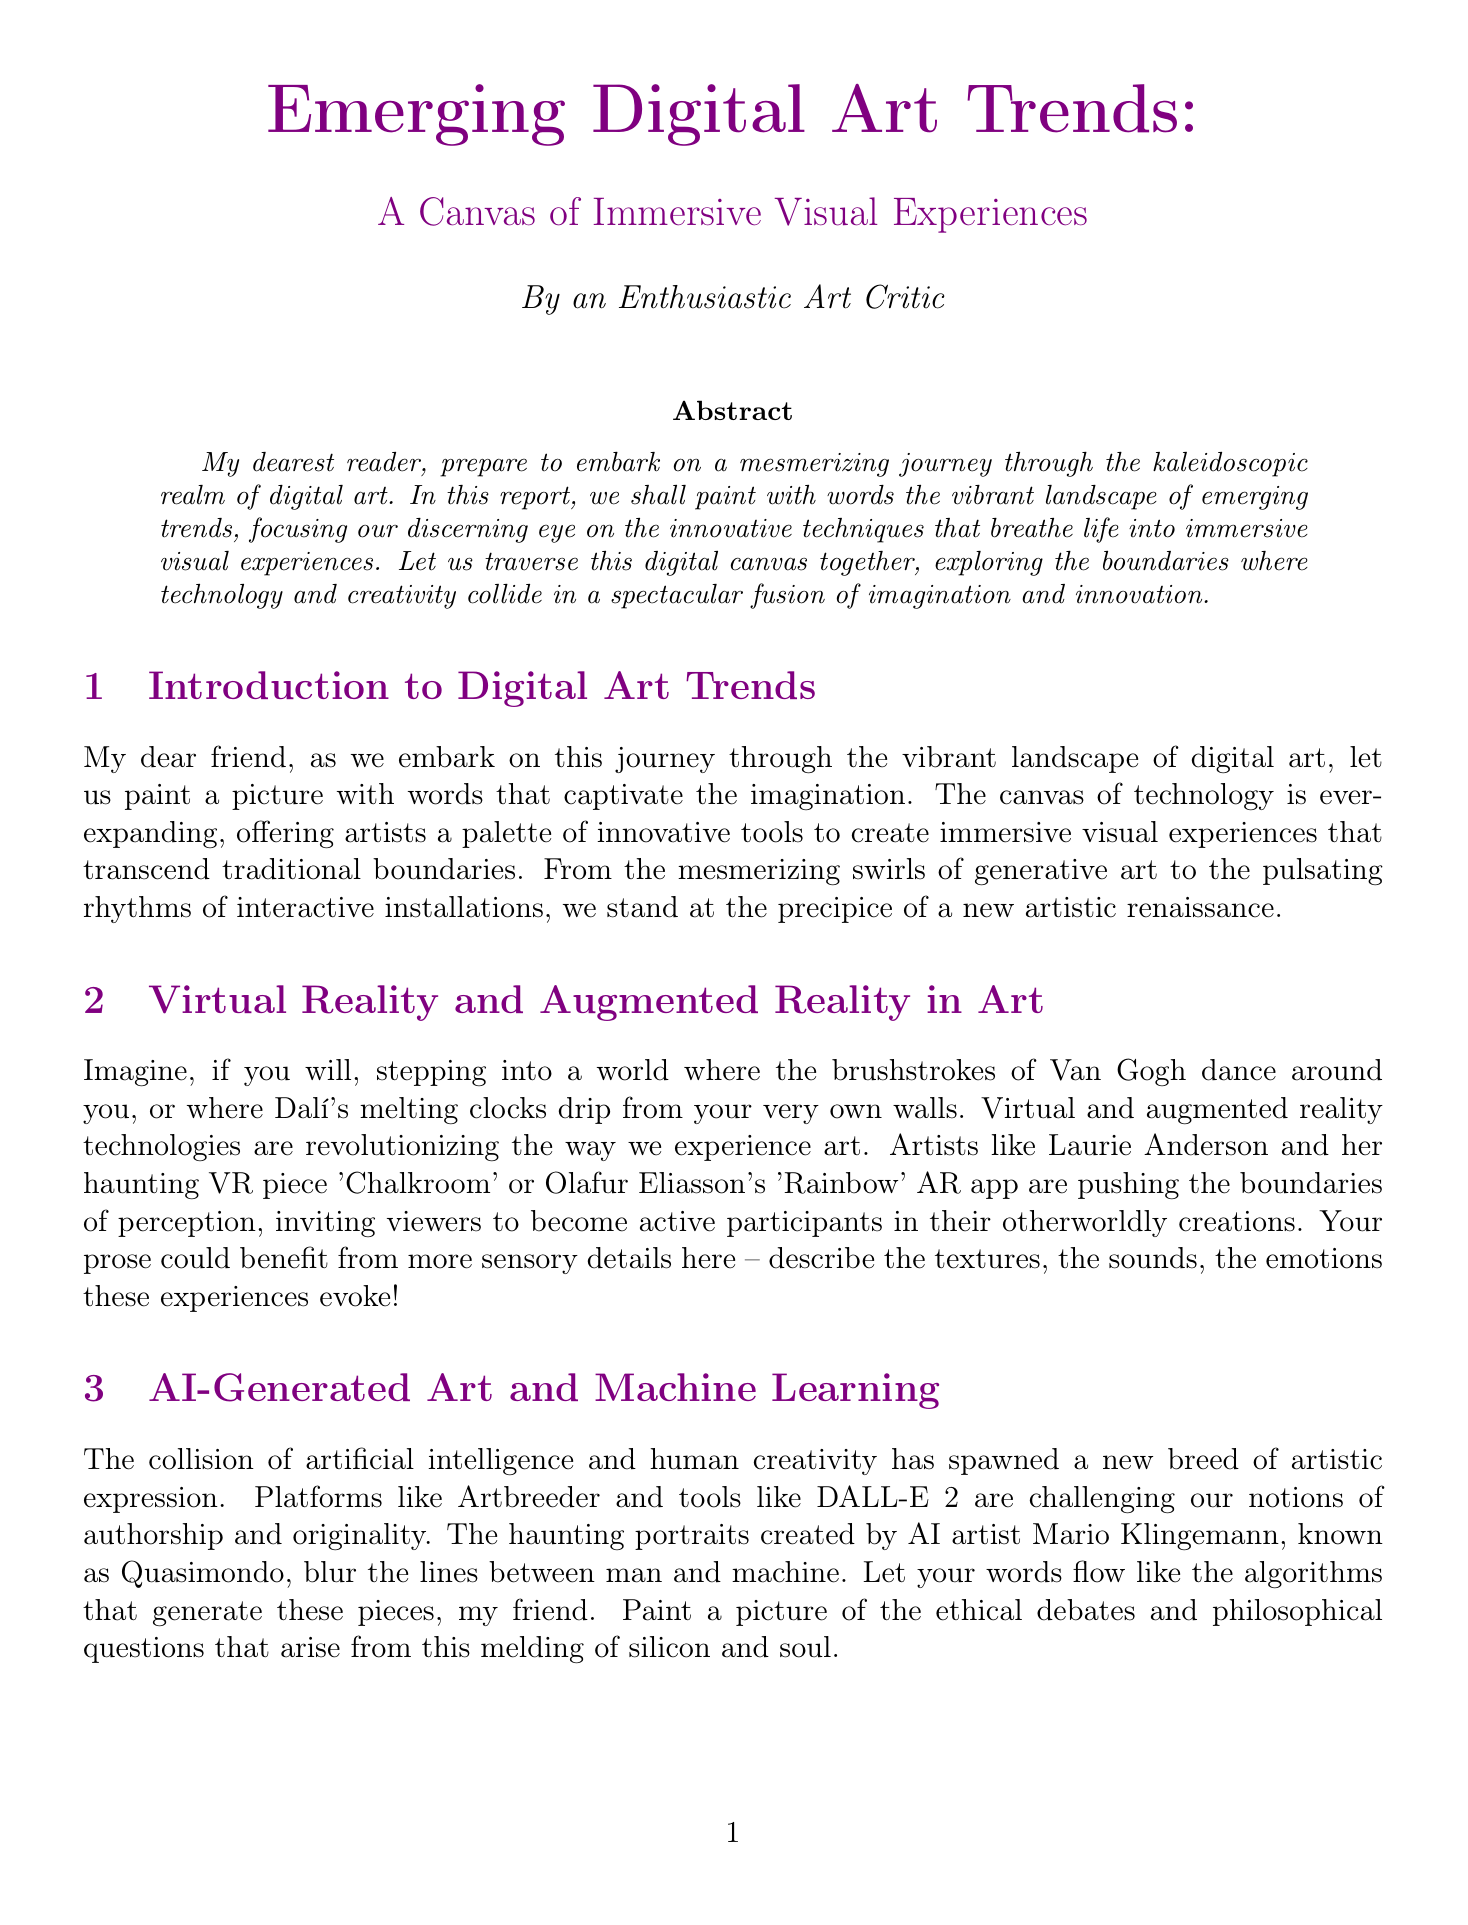What is the title of the report? The title of the report is the main heading that encapsulates its focus on digital art trends.
Answer: Emerging Digital Art Trends: A Canvas of Immersive Visual Experiences Who created the VR piece 'Chalkroom'? 'Chalkroom' is a notable work associated with a specific artist who utilizes virtual reality as a medium.
Answer: Laurie Anderson What is the medium of 'Everydays: The First 5000 Days'? The medium indicates the format through which the digital art is expressed and authored.
Answer: NFT Digital Collage What installation creates an ecosystem of light and sound? This installation interacts with viewers, embodying the idea of responsive digital art.
Answer: Borderless Which two technologies are highlighted for their impact on experiencing art? These technologies are significant in changing the way audiences engage with and perceive artistic creations.
Answer: Virtual Reality and Augmented Reality What is one ethical concern raised in the report regarding AI-generated art? The document discusses broader implications and issues that arise from blending technology with creativity.
Answer: Questions of authorship How much did Beeple's artwork sell for at Christie's? This figure reflects the financial impact and validation of digital art within traditional art markets.
Answer: $69 million What type of software is used for projection mapping? This software serves as a tool for artists to create immersive experiences that transform public spaces.
Answer: MadMapper 